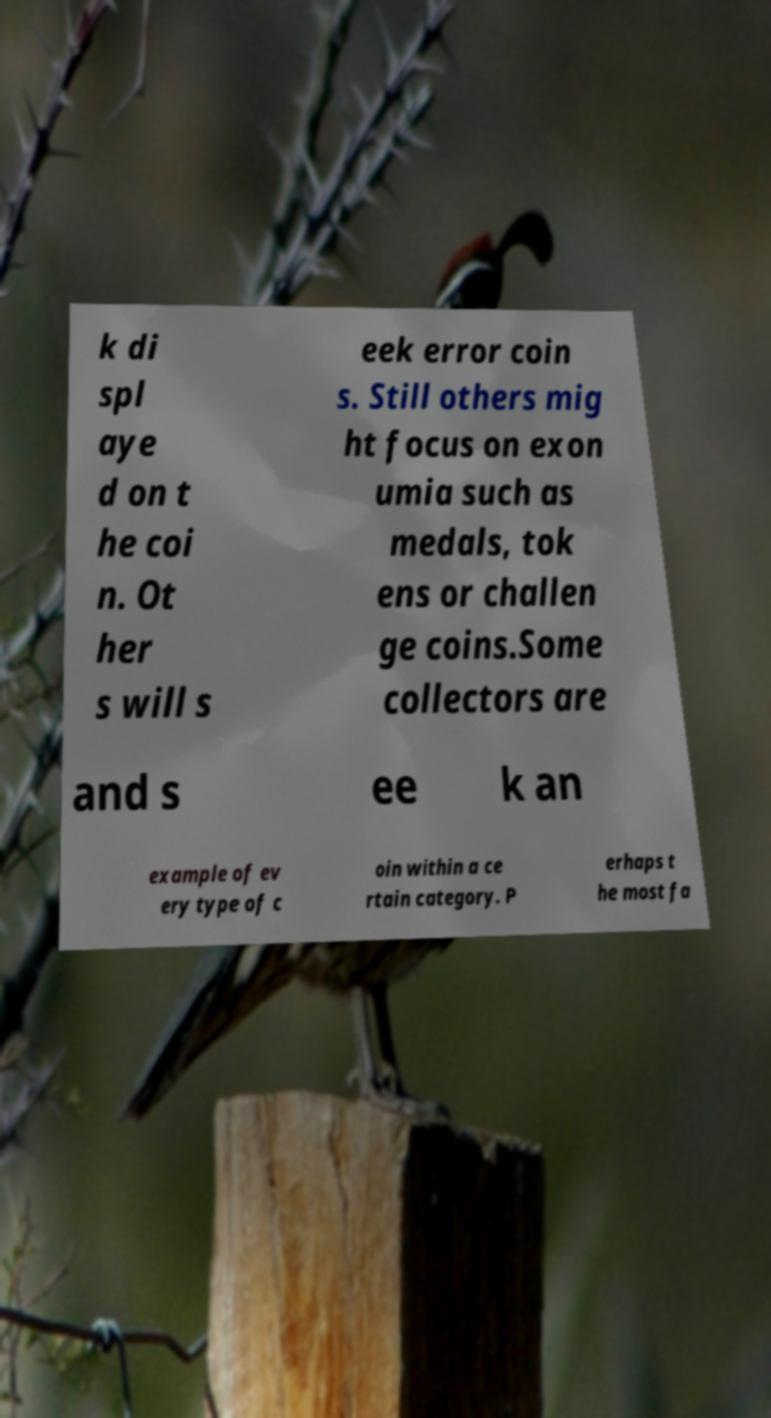I need the written content from this picture converted into text. Can you do that? k di spl aye d on t he coi n. Ot her s will s eek error coin s. Still others mig ht focus on exon umia such as medals, tok ens or challen ge coins.Some collectors are and s ee k an example of ev ery type of c oin within a ce rtain category. P erhaps t he most fa 